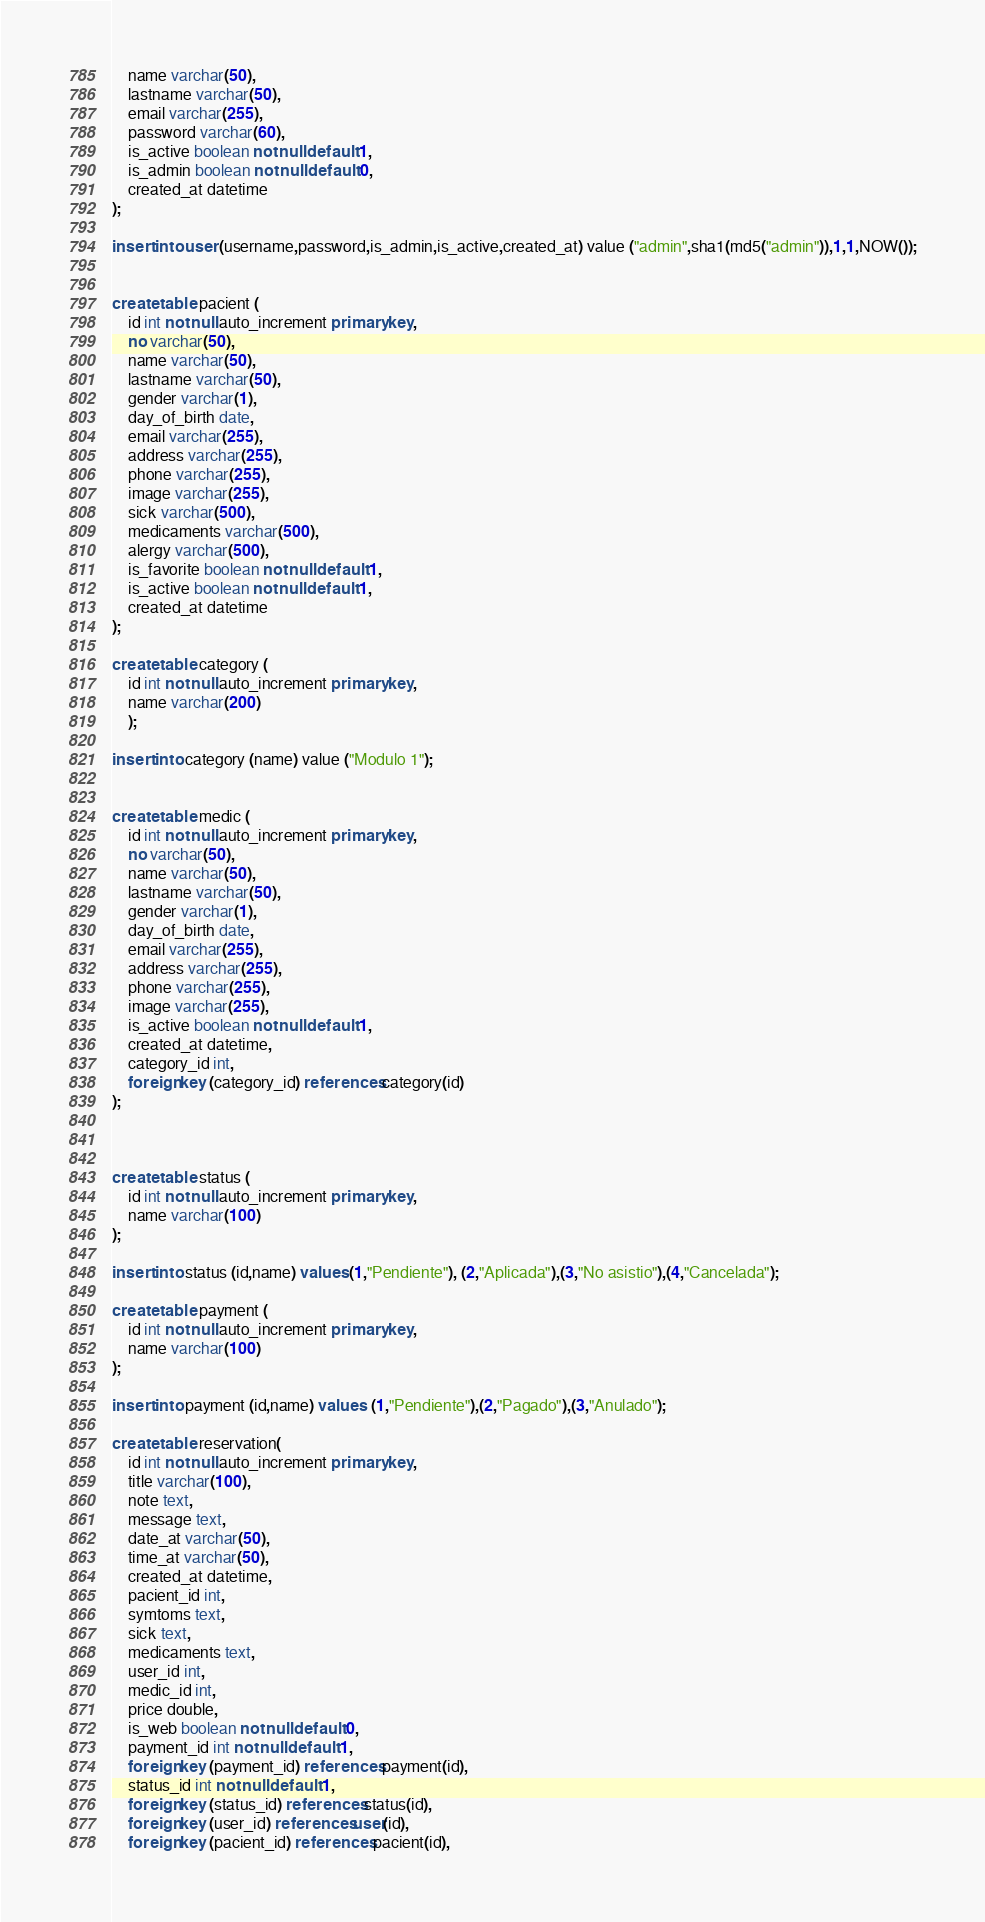<code> <loc_0><loc_0><loc_500><loc_500><_SQL_>	name varchar(50),
	lastname varchar(50),
	email varchar(255),
	password varchar(60),
	is_active boolean not null default 1,
	is_admin boolean not null default 0,
	created_at datetime
);

insert into user (username,password,is_admin,is_active,created_at) value ("admin",sha1(md5("admin")),1,1,NOW());


create table pacient (
	id int not null auto_increment primary key,
	no varchar(50),
	name varchar(50),
	lastname varchar(50),
	gender varchar(1),
	day_of_birth date,
	email varchar(255),
	address varchar(255),
	phone varchar(255),
	image varchar(255),
	sick varchar(500),
	medicaments varchar(500),
	alergy varchar(500),
	is_favorite boolean not null default 1,
	is_active boolean not null default 1,
	created_at datetime
);

create table category (
	id int not null auto_increment primary key,
	name varchar(200)
	);

insert into category (name) value ("Modulo 1");


create table medic (
	id int not null auto_increment primary key,
	no varchar(50),
	name varchar(50),
	lastname varchar(50),
	gender varchar(1),
	day_of_birth date,
	email varchar(255),
	address varchar(255),
	phone varchar(255),
	image varchar(255),
	is_active boolean not null default 1,
	created_at datetime,
	category_id int,
	foreign key (category_id) references category(id)
);



create table status (
	id int not null auto_increment primary key,
	name varchar(100)
);

insert into status (id,name) values (1,"Pendiente"), (2,"Aplicada"),(3,"No asistio"),(4,"Cancelada");

create table payment (
	id int not null auto_increment primary key,
	name varchar(100)
);

insert into payment (id,name) values  (1,"Pendiente"),(2,"Pagado"),(3,"Anulado");

create table reservation(
	id int not null auto_increment primary key,
	title varchar(100),
	note text,
	message text,
	date_at varchar(50),
	time_at varchar(50),
	created_at datetime,
	pacient_id int,
	symtoms text,
	sick text,
	medicaments text,
	user_id int,
	medic_id int,
	price double,
	is_web boolean not null default 0,
	payment_id int not null default 1,
	foreign key (payment_id) references payment(id),
	status_id int not null default 1,
	foreign key (status_id) references status(id),
	foreign key (user_id) references user(id),
	foreign key (pacient_id) references pacient(id),</code> 